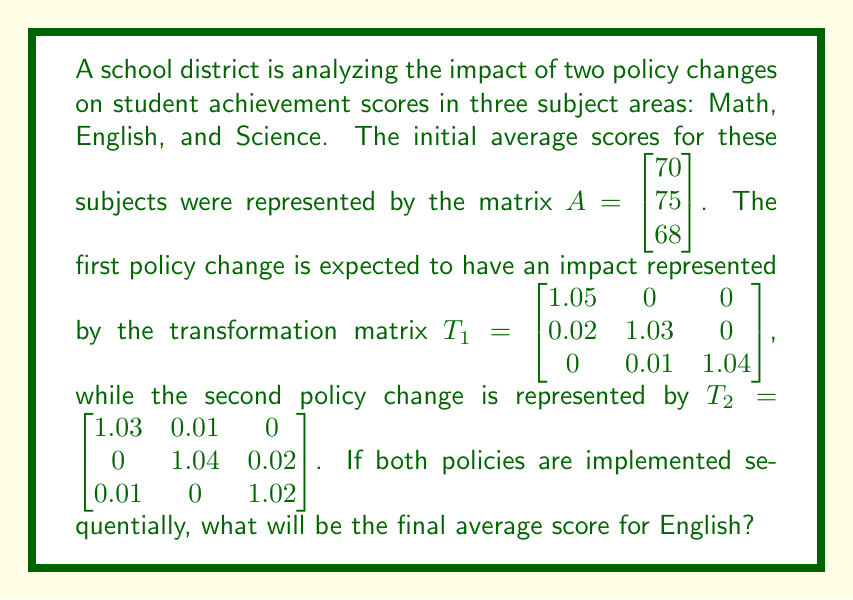Can you answer this question? To solve this problem, we need to apply the matrix transformations sequentially to the initial scores. Let's break it down step-by-step:

1) First, we apply the transformation $T_1$ to the initial scores $A$:
   $B = T_1A = \begin{bmatrix} 1.05 & 0 & 0 \\ 0.02 & 1.03 & 0 \\ 0 & 0.01 & 1.04 \end{bmatrix} \begin{bmatrix} 70 \\ 75 \\ 68 \end{bmatrix}$

2) Calculating $B$:
   $B = \begin{bmatrix} (1.05)(70) + (0)(75) + (0)(68) \\ (0.02)(70) + (1.03)(75) + (0)(68) \\ (0)(70) + (0.01)(75) + (1.04)(68) \end{bmatrix} = \begin{bmatrix} 73.5 \\ 78.65 \\ 71.07 \end{bmatrix}$

3) Now, we apply the second transformation $T_2$ to the result $B$:
   $C = T_2B = \begin{bmatrix} 1.03 & 0.01 & 0 \\ 0 & 1.04 & 0.02 \\ 0.01 & 0 & 1.02 \end{bmatrix} \begin{bmatrix} 73.5 \\ 78.65 \\ 71.07 \end{bmatrix}$

4) Calculating $C$:
   $C = \begin{bmatrix} (1.03)(73.5) + (0.01)(78.65) + (0)(71.07) \\ (0)(73.5) + (1.04)(78.65) + (0.02)(71.07) \\ (0.01)(73.5) + (0)(78.65) + (1.02)(71.07) \end{bmatrix}$

5) Simplifying:
   $C = \begin{bmatrix} 75.7055 + 0.7865 \\ 81.796 + 1.4214 \\ 0.735 + 72.4914 \end{bmatrix} = \begin{bmatrix} 76.492 \\ 83.2174 \\ 73.2264 \end{bmatrix}$

6) The final average score for English (the second component of the resulting matrix) is approximately 83.22.
Answer: 83.22 